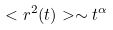<formula> <loc_0><loc_0><loc_500><loc_500>< r ^ { 2 } ( t ) > \sim t ^ { \alpha }</formula> 